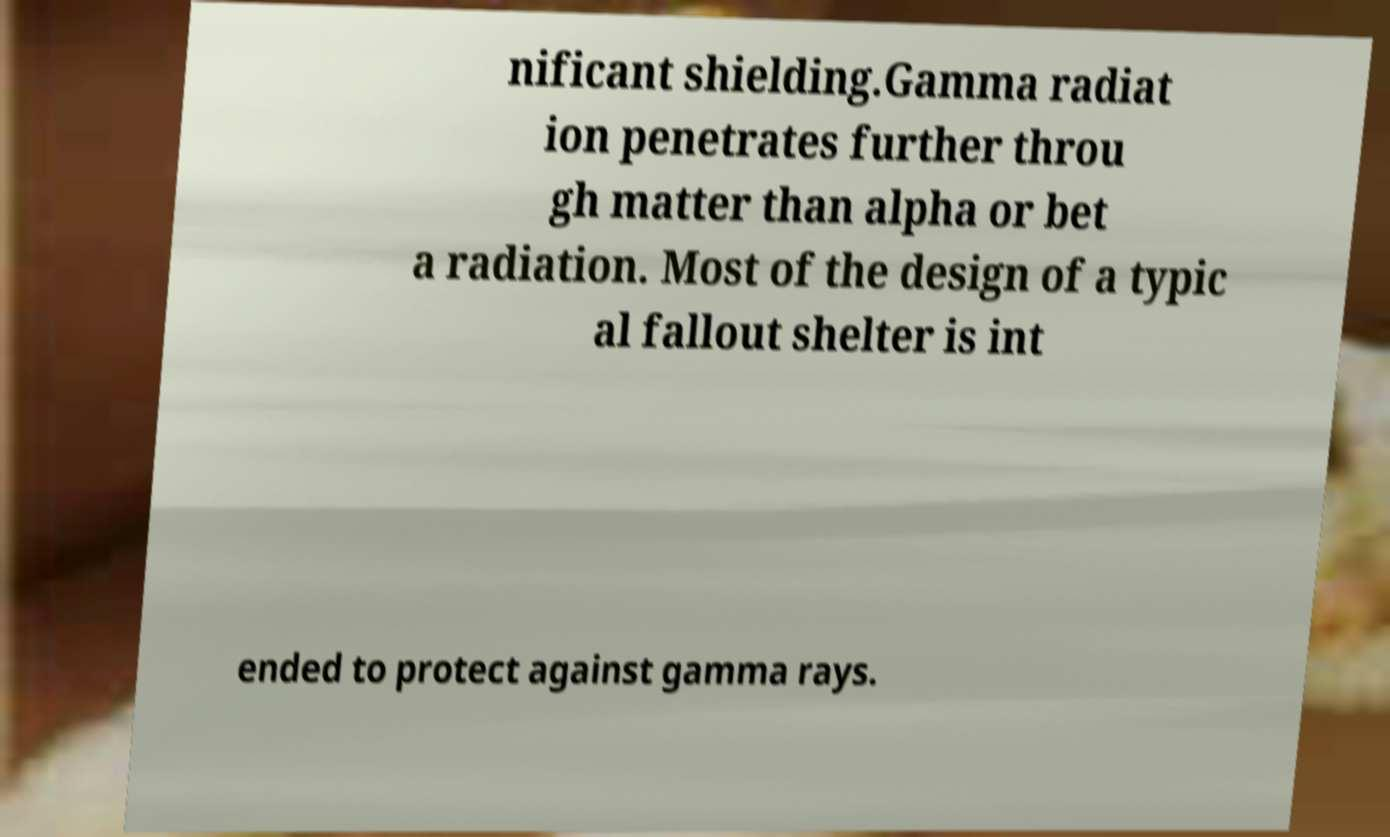Can you accurately transcribe the text from the provided image for me? nificant shielding.Gamma radiat ion penetrates further throu gh matter than alpha or bet a radiation. Most of the design of a typic al fallout shelter is int ended to protect against gamma rays. 